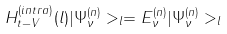<formula> <loc_0><loc_0><loc_500><loc_500>H _ { t - V } ^ { ( i n t r a ) } ( l ) | \Psi _ { \nu } ^ { ( n ) } > _ { l } = E _ { \nu } ^ { ( n ) } | \Psi _ { \nu } ^ { ( n ) } > _ { l }</formula> 